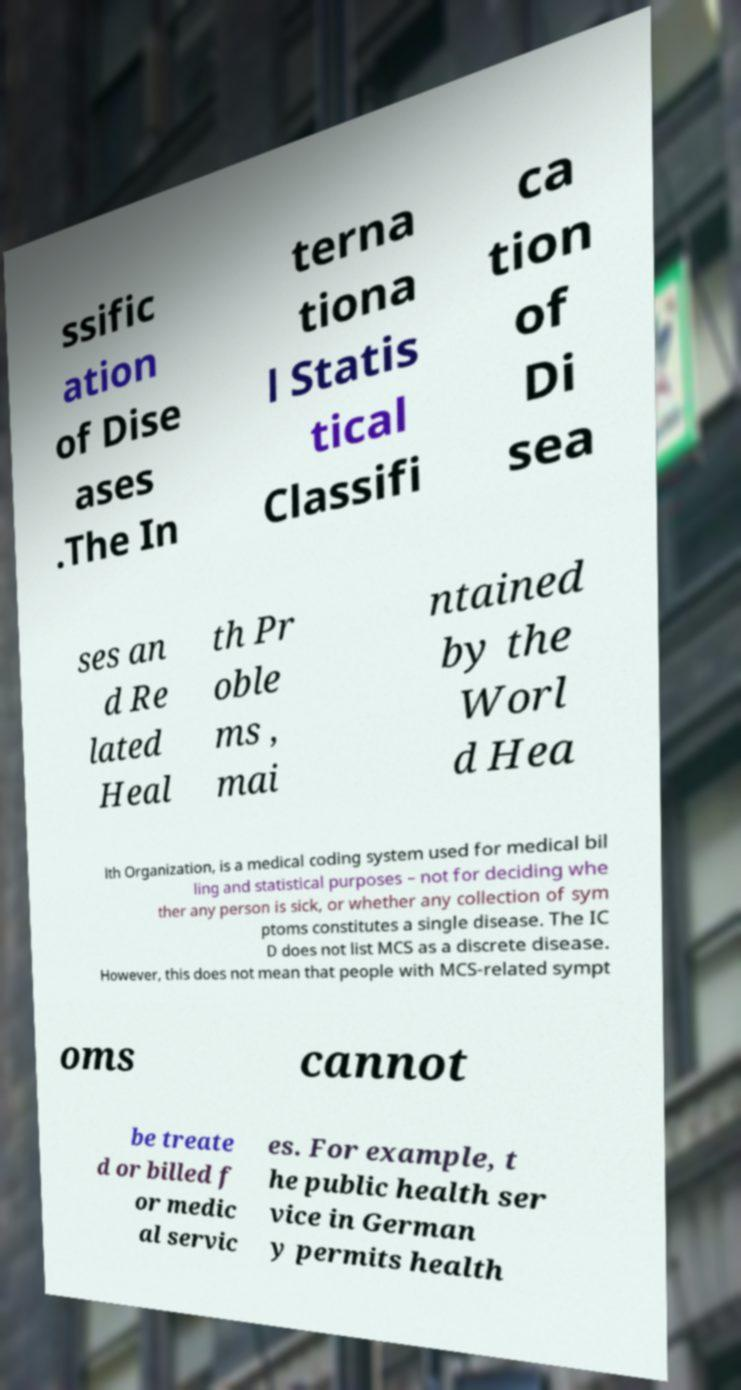Could you extract and type out the text from this image? ssific ation of Dise ases .The In terna tiona l Statis tical Classifi ca tion of Di sea ses an d Re lated Heal th Pr oble ms , mai ntained by the Worl d Hea lth Organization, is a medical coding system used for medical bil ling and statistical purposes – not for deciding whe ther any person is sick, or whether any collection of sym ptoms constitutes a single disease. The IC D does not list MCS as a discrete disease. However, this does not mean that people with MCS-related sympt oms cannot be treate d or billed f or medic al servic es. For example, t he public health ser vice in German y permits health 